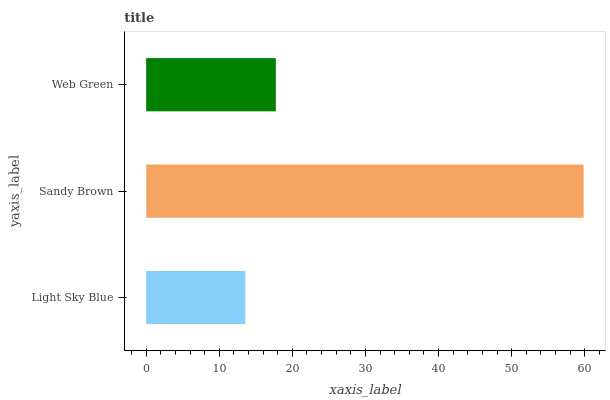Is Light Sky Blue the minimum?
Answer yes or no. Yes. Is Sandy Brown the maximum?
Answer yes or no. Yes. Is Web Green the minimum?
Answer yes or no. No. Is Web Green the maximum?
Answer yes or no. No. Is Sandy Brown greater than Web Green?
Answer yes or no. Yes. Is Web Green less than Sandy Brown?
Answer yes or no. Yes. Is Web Green greater than Sandy Brown?
Answer yes or no. No. Is Sandy Brown less than Web Green?
Answer yes or no. No. Is Web Green the high median?
Answer yes or no. Yes. Is Web Green the low median?
Answer yes or no. Yes. Is Light Sky Blue the high median?
Answer yes or no. No. Is Sandy Brown the low median?
Answer yes or no. No. 